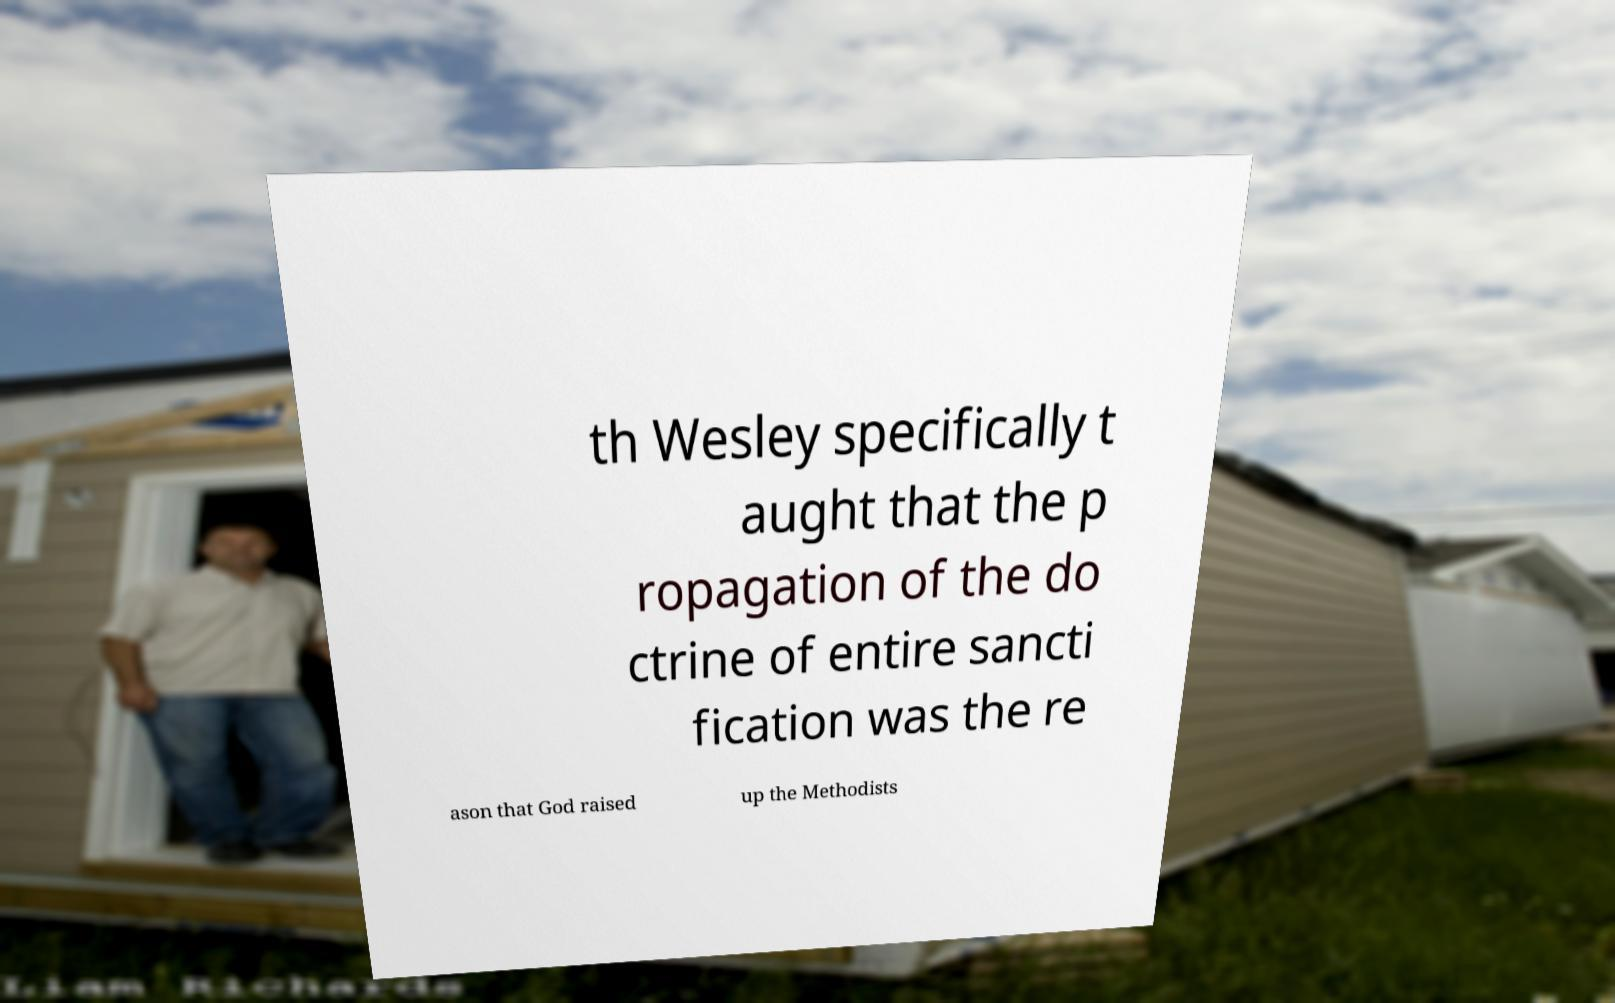Please identify and transcribe the text found in this image. th Wesley specifically t aught that the p ropagation of the do ctrine of entire sancti fication was the re ason that God raised up the Methodists 